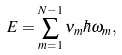<formula> <loc_0><loc_0><loc_500><loc_500>E = \sum _ { m = 1 } ^ { N - 1 } \nu _ { m } \hbar { \omega } _ { m } ,</formula> 